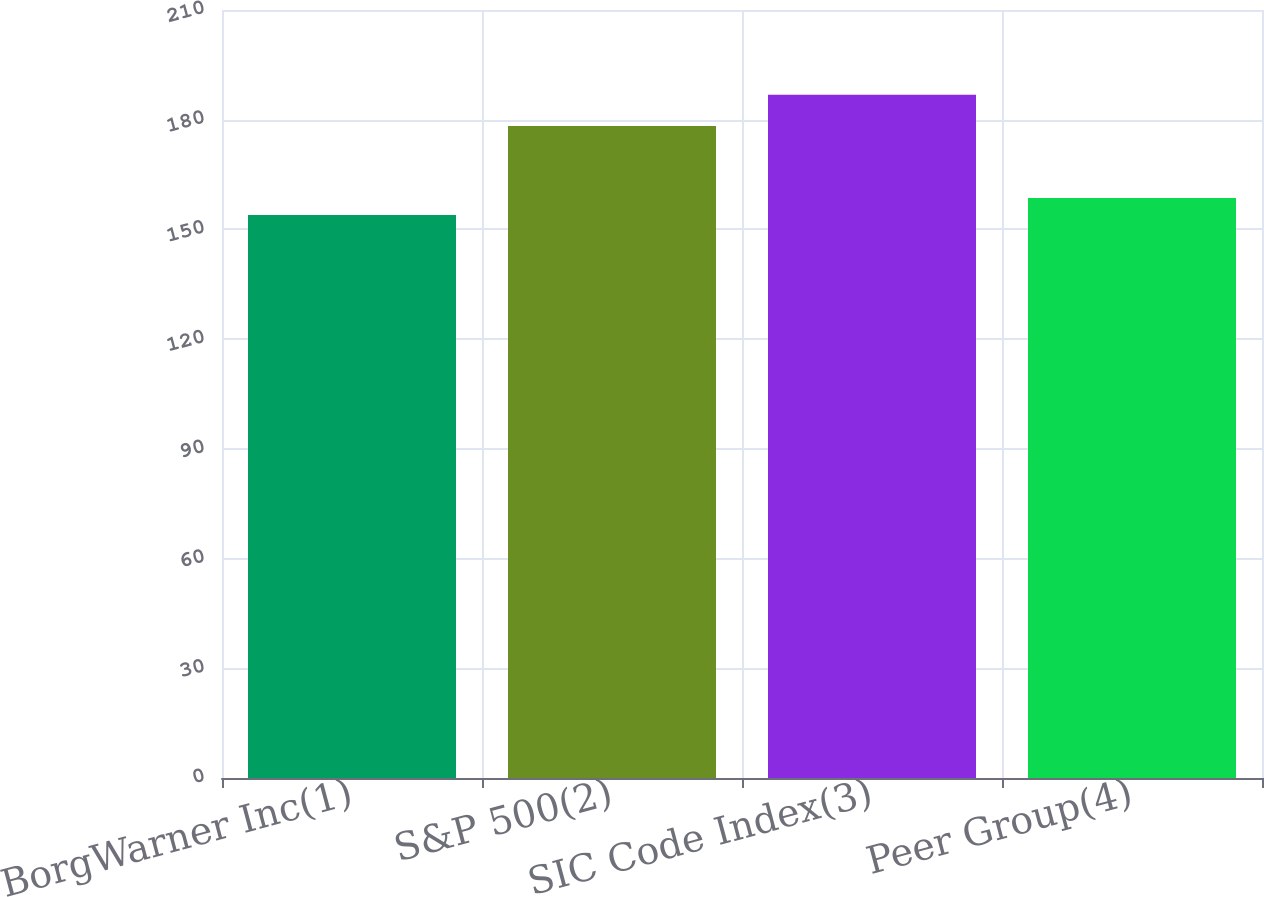<chart> <loc_0><loc_0><loc_500><loc_500><bar_chart><fcel>BorgWarner Inc(1)<fcel>S&P 500(2)<fcel>SIC Code Index(3)<fcel>Peer Group(4)<nl><fcel>153.97<fcel>178.29<fcel>186.8<fcel>158.58<nl></chart> 